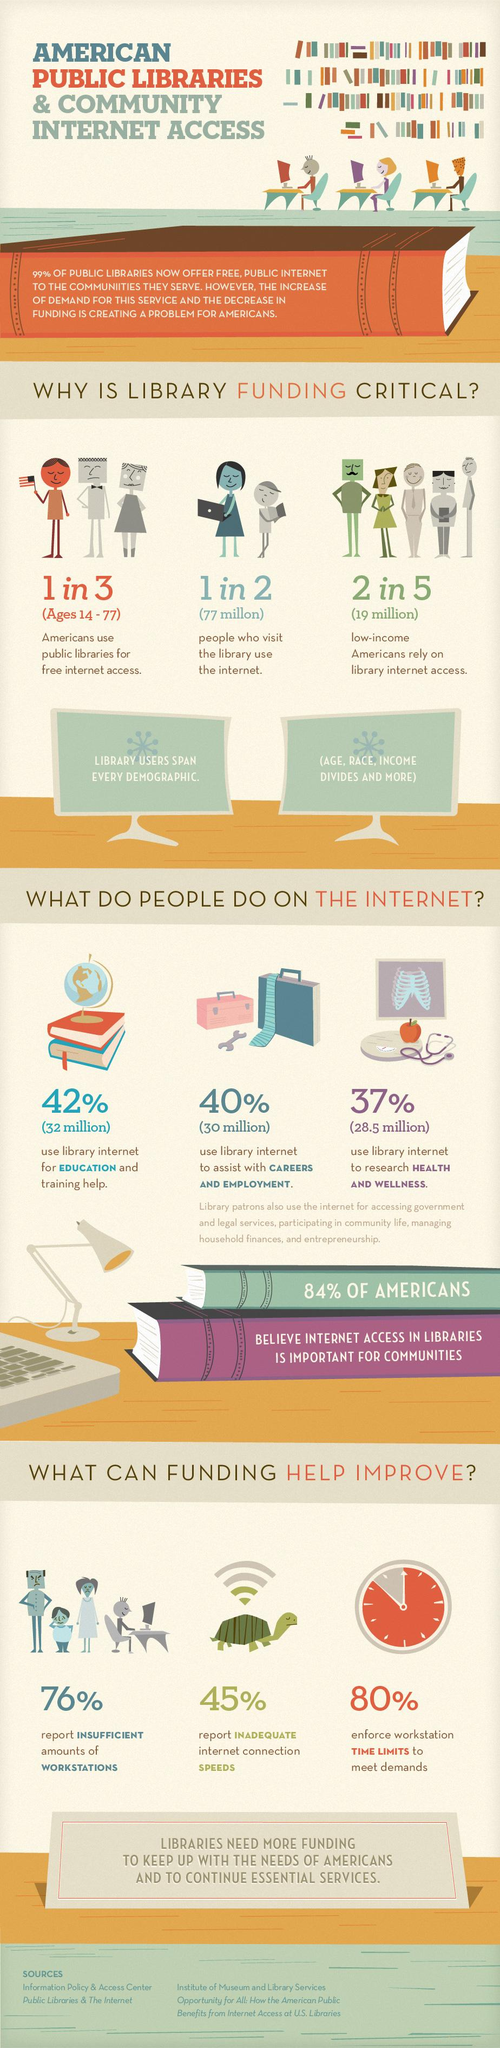Draw attention to some important aspects in this diagram. According to a recent survey, 42% of Americans rely on library internet to help with their education and training. According to a survey, 16% of Americans do not believe that internet access in libraries is important for communities. According to a recent survey, 24% of Americans report having access to sufficient workstations in libraries. Approximately 77 million Americans visit libraries to access the internet. Approximately 20% of Americans do not enforce workstation time limits to meet demands. 